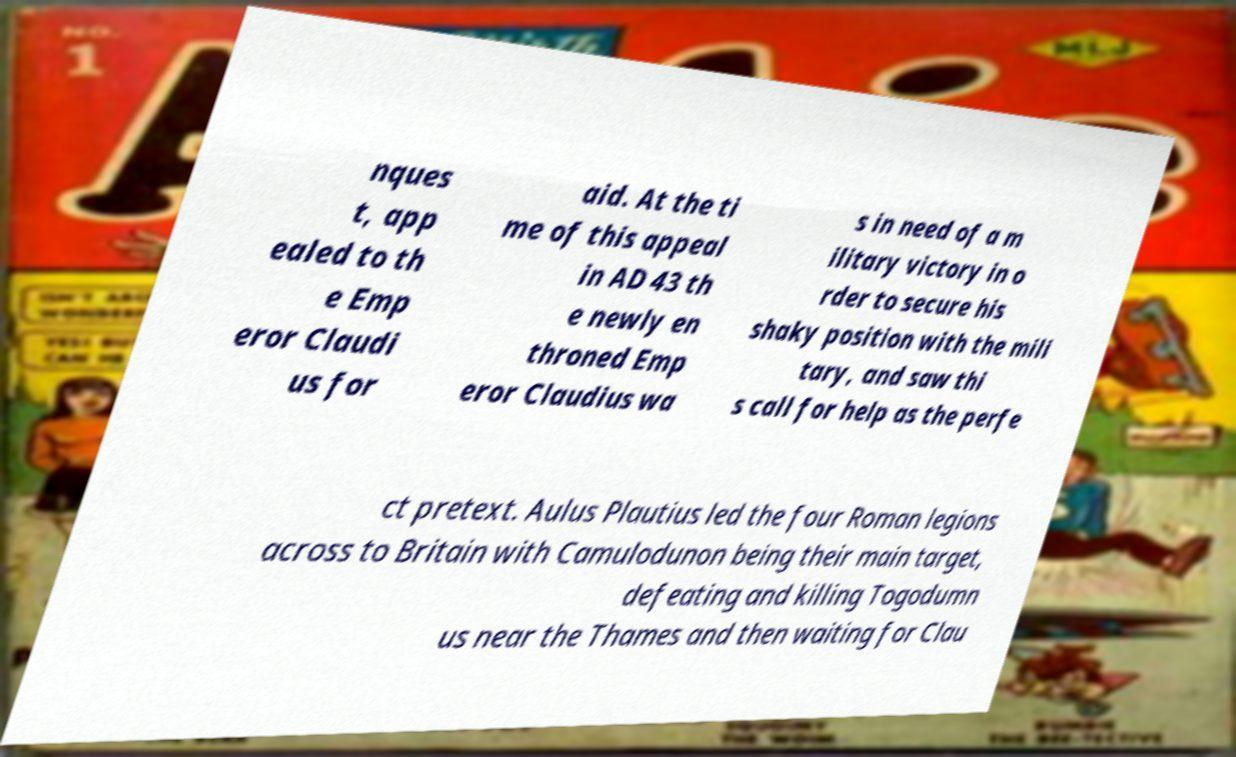I need the written content from this picture converted into text. Can you do that? nques t, app ealed to th e Emp eror Claudi us for aid. At the ti me of this appeal in AD 43 th e newly en throned Emp eror Claudius wa s in need of a m ilitary victory in o rder to secure his shaky position with the mili tary, and saw thi s call for help as the perfe ct pretext. Aulus Plautius led the four Roman legions across to Britain with Camulodunon being their main target, defeating and killing Togodumn us near the Thames and then waiting for Clau 